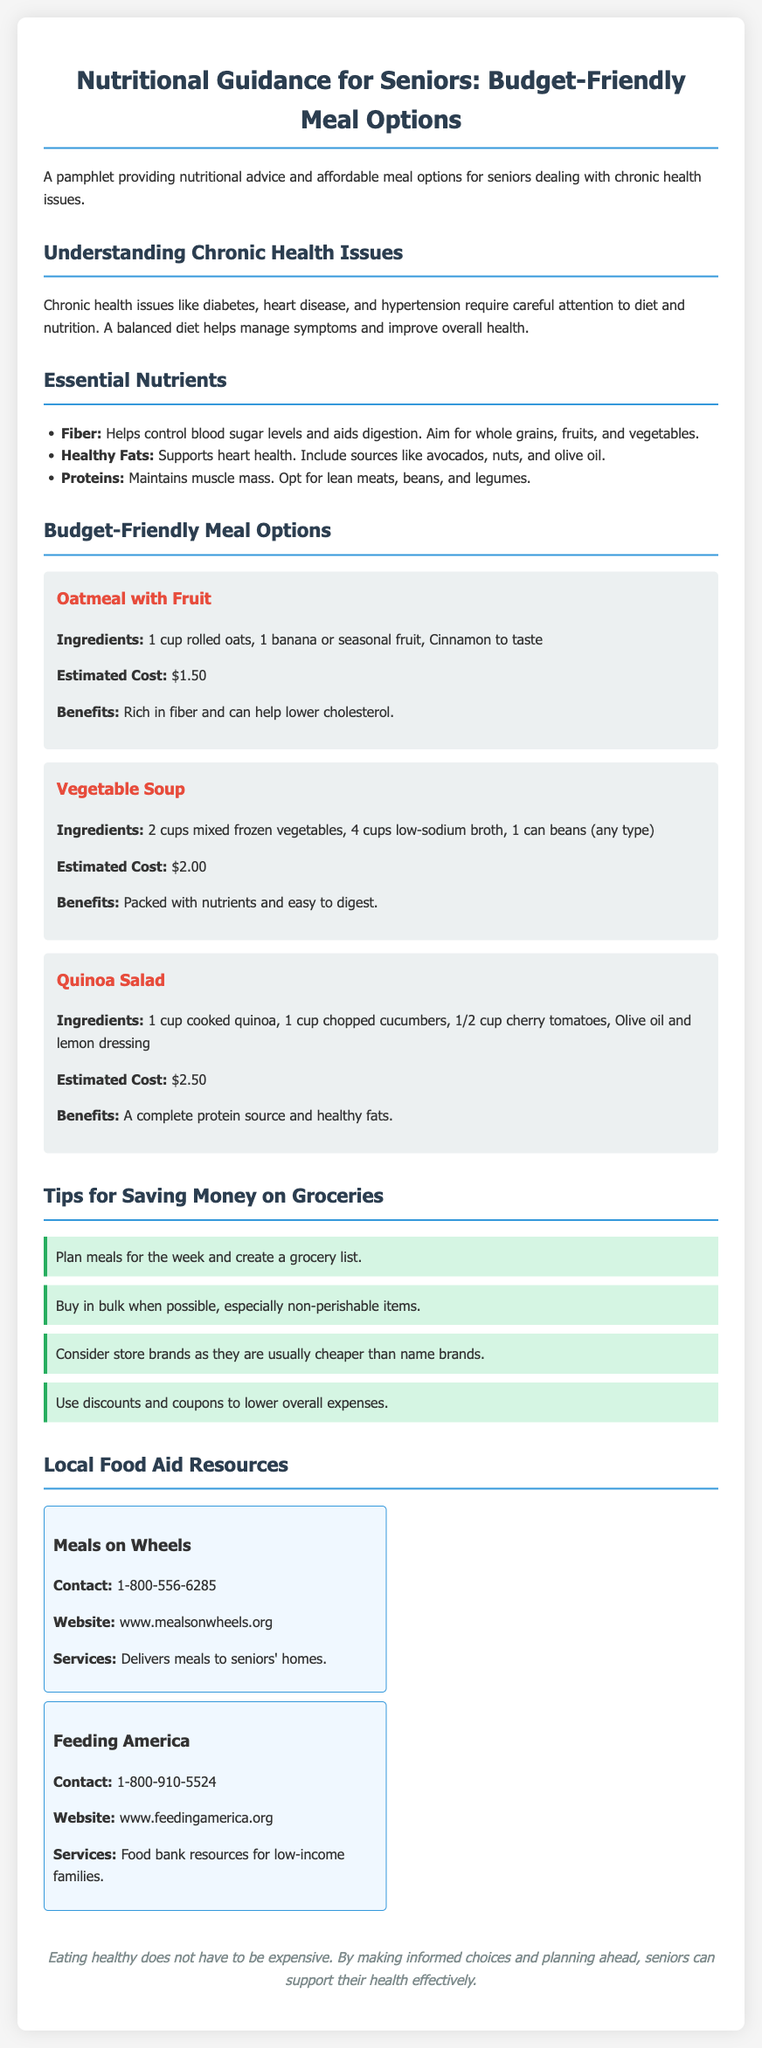What are chronic health issues? Chronic health issues are conditions that require careful attention to diet and nutrition, including diabetes, heart disease, and hypertension.
Answer: diabetes, heart disease, hypertension What is the estimated cost of Vegetable Soup? The estimated cost for the Vegetable Soup meal option is specifically mentioned in the document.
Answer: $2.00 Which organization delivers meals to seniors' homes? The document specifies the organization that provides meal delivery services to seniors.
Answer: Meals on Wheels What is the main benefit of oatmeal with fruit? The document outlines the primary benefit of oatmeal with fruit in the meal options section.
Answer: Rich in fiber and can help lower cholesterol What is one tip for saving money on groceries? The document includes several tips for saving money; one is specifically mentioned.
Answer: Plan meals for the week and create a grocery list 